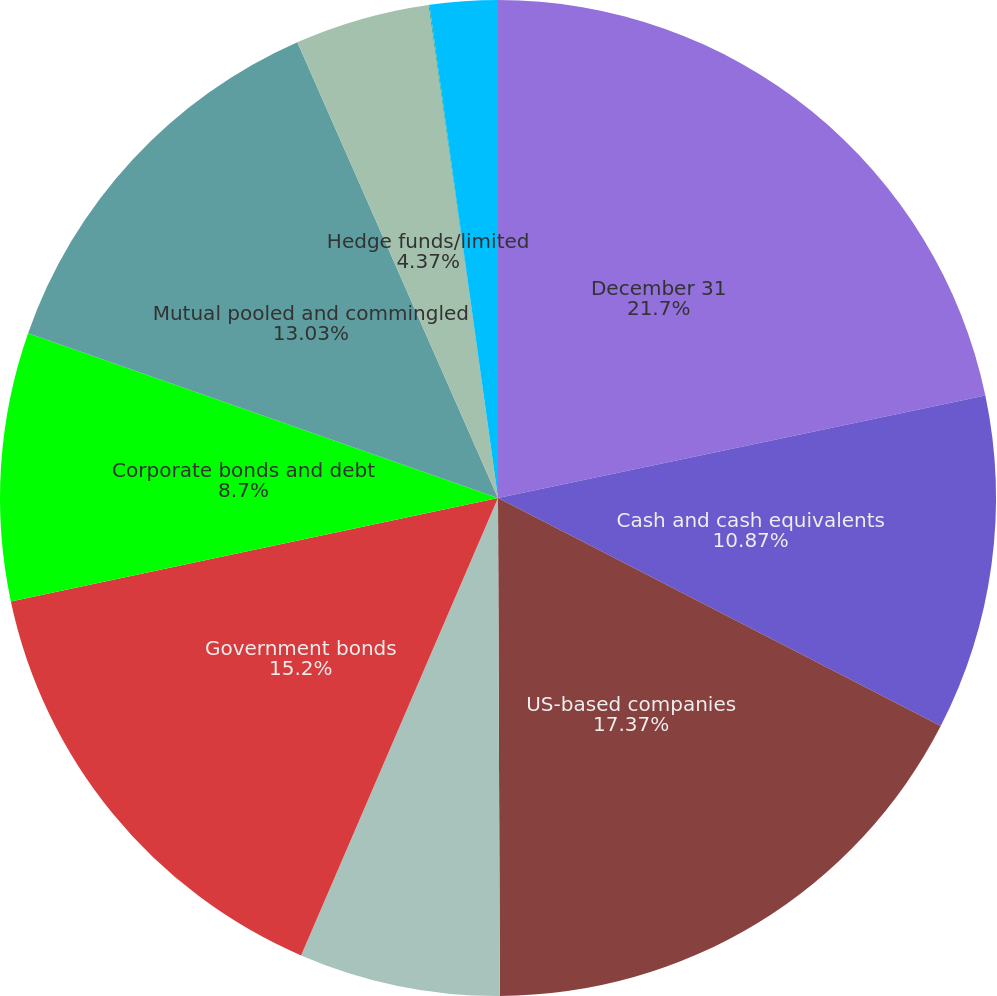Convert chart. <chart><loc_0><loc_0><loc_500><loc_500><pie_chart><fcel>December 31<fcel>Cash and cash equivalents<fcel>US-based companies<fcel>International-based companies<fcel>Government bonds<fcel>Corporate bonds and debt<fcel>Mutual pooled and commingled<fcel>Hedge funds/limited<fcel>Real estate<fcel>Other<nl><fcel>21.7%<fcel>10.87%<fcel>17.37%<fcel>6.53%<fcel>15.2%<fcel>8.7%<fcel>13.03%<fcel>4.37%<fcel>0.03%<fcel>2.2%<nl></chart> 